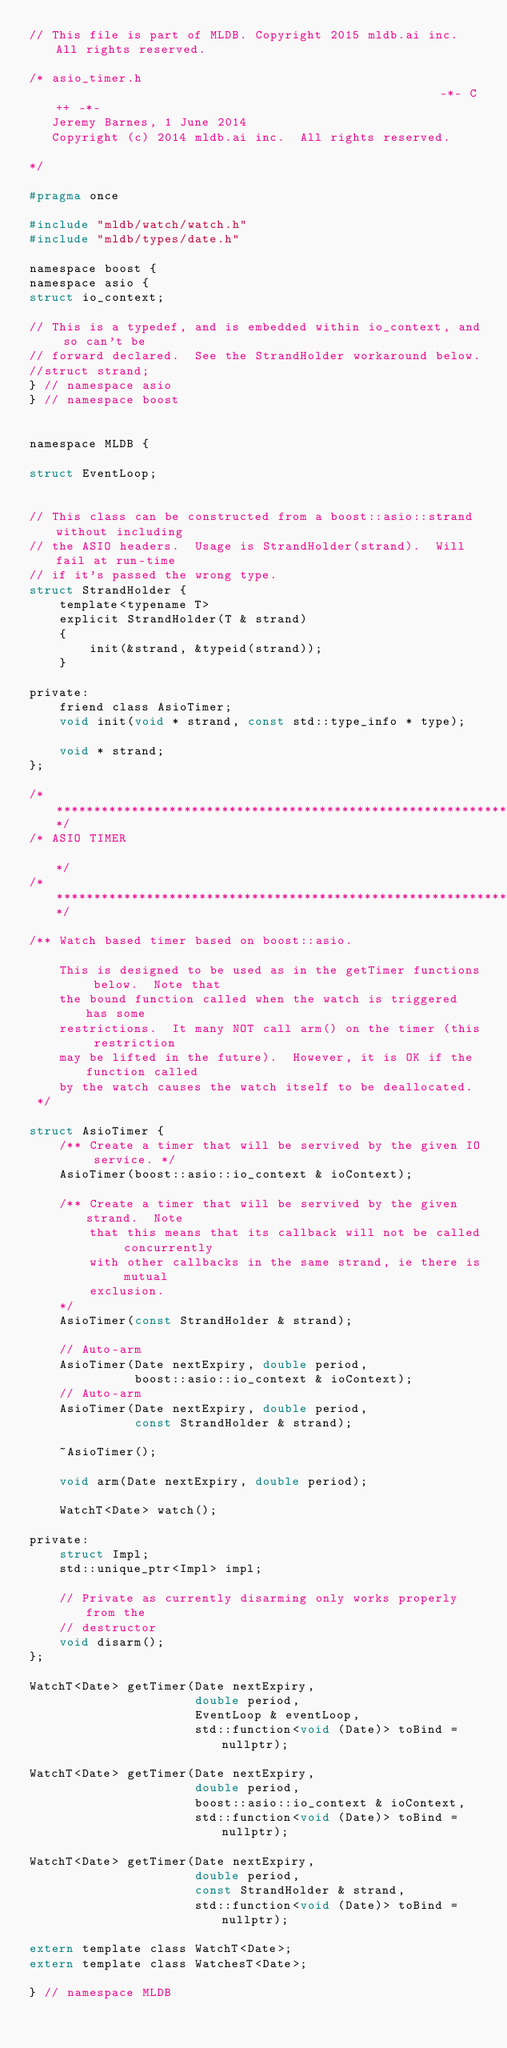Convert code to text. <code><loc_0><loc_0><loc_500><loc_500><_C_>// This file is part of MLDB. Copyright 2015 mldb.ai inc. All rights reserved.

/* asio_timer.h                                                    -*- C++ -*-
   Jeremy Barnes, 1 June 2014
   Copyright (c) 2014 mldb.ai inc.  All rights reserved.

*/

#pragma once

#include "mldb/watch/watch.h"
#include "mldb/types/date.h"

namespace boost {
namespace asio {
struct io_context;

// This is a typedef, and is embedded within io_context, and so can't be
// forward declared.  See the StrandHolder workaround below.
//struct strand;
} // namespace asio
} // namespace boost


namespace MLDB {

struct EventLoop;


// This class can be constructed from a boost::asio::strand without including
// the ASIO headers.  Usage is StrandHolder(strand).  Will fail at run-time
// if it's passed the wrong type.
struct StrandHolder {
    template<typename T>
    explicit StrandHolder(T & strand)
    {
        init(&strand, &typeid(strand));
    }

private:
    friend class AsioTimer;
    void init(void * strand, const std::type_info * type);
        
    void * strand;
};

/*****************************************************************************/
/* ASIO TIMER                                                                */
/*****************************************************************************/

/** Watch based timer based on boost::asio. 

    This is designed to be used as in the getTimer functions below.  Note that
    the bound function called when the watch is triggered has some
    restrictions.  It many NOT call arm() on the timer (this restriction
    may be lifted in the future).  However, it is OK if the function called
    by the watch causes the watch itself to be deallocated.
 */

struct AsioTimer {
    /** Create a timer that will be servived by the given IO service. */
    AsioTimer(boost::asio::io_context & ioContext);

    /** Create a timer that will be servived by the given strand.  Note
        that this means that its callback will not be called concurrently
        with other callbacks in the same strand, ie there is mutual
        exclusion.
    */
    AsioTimer(const StrandHolder & strand);

    // Auto-arm
    AsioTimer(Date nextExpiry, double period,
              boost::asio::io_context & ioContext);
    // Auto-arm
    AsioTimer(Date nextExpiry, double period,
              const StrandHolder & strand);

    ~AsioTimer();

    void arm(Date nextExpiry, double period);

    WatchT<Date> watch();

private:
    struct Impl;
    std::unique_ptr<Impl> impl;
    
    // Private as currently disarming only works properly from the
    // destructor
    void disarm();
};

WatchT<Date> getTimer(Date nextExpiry,
                      double period,
                      EventLoop & eventLoop,
                      std::function<void (Date)> toBind = nullptr);

WatchT<Date> getTimer(Date nextExpiry,
                      double period,
                      boost::asio::io_context & ioContext,
                      std::function<void (Date)> toBind = nullptr);

WatchT<Date> getTimer(Date nextExpiry,
                      double period,
                      const StrandHolder & strand,
                      std::function<void (Date)> toBind = nullptr);

extern template class WatchT<Date>;
extern template class WatchesT<Date>;

} // namespace MLDB
</code> 